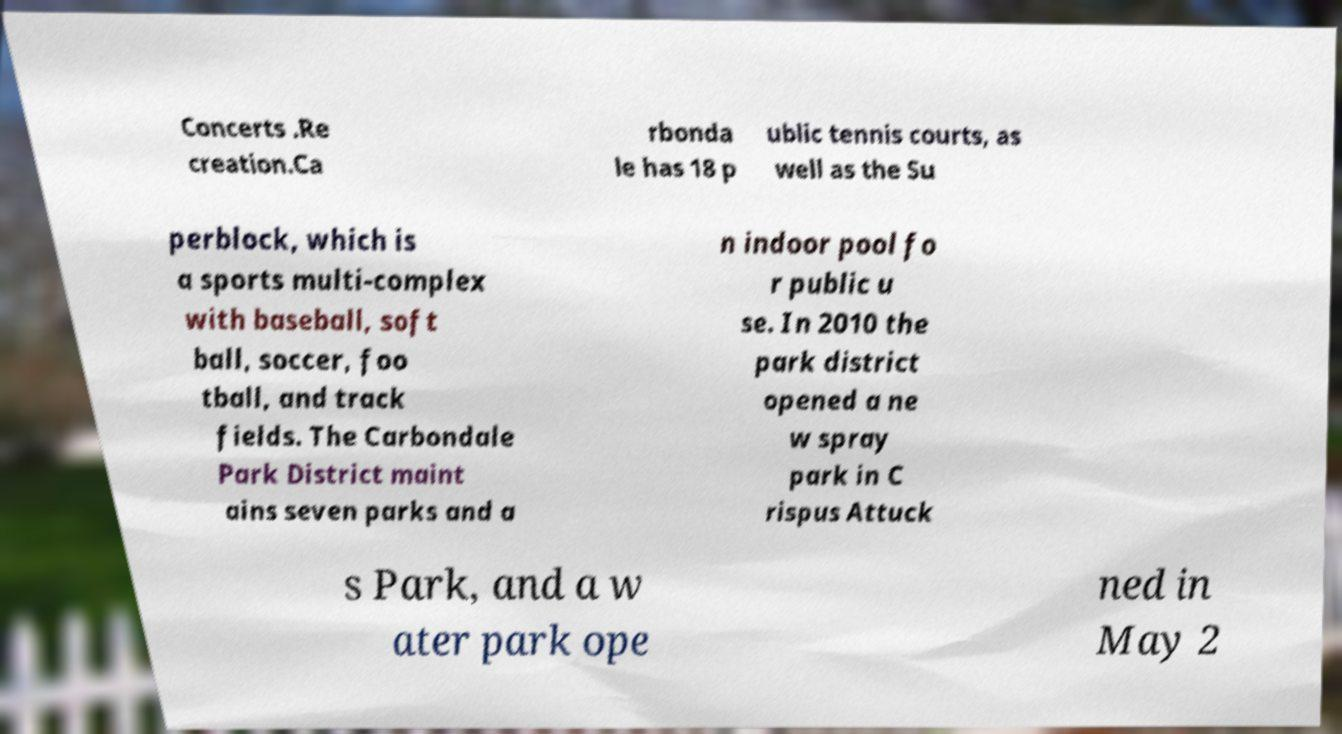Can you read and provide the text displayed in the image?This photo seems to have some interesting text. Can you extract and type it out for me? Concerts .Re creation.Ca rbonda le has 18 p ublic tennis courts, as well as the Su perblock, which is a sports multi-complex with baseball, soft ball, soccer, foo tball, and track fields. The Carbondale Park District maint ains seven parks and a n indoor pool fo r public u se. In 2010 the park district opened a ne w spray park in C rispus Attuck s Park, and a w ater park ope ned in May 2 